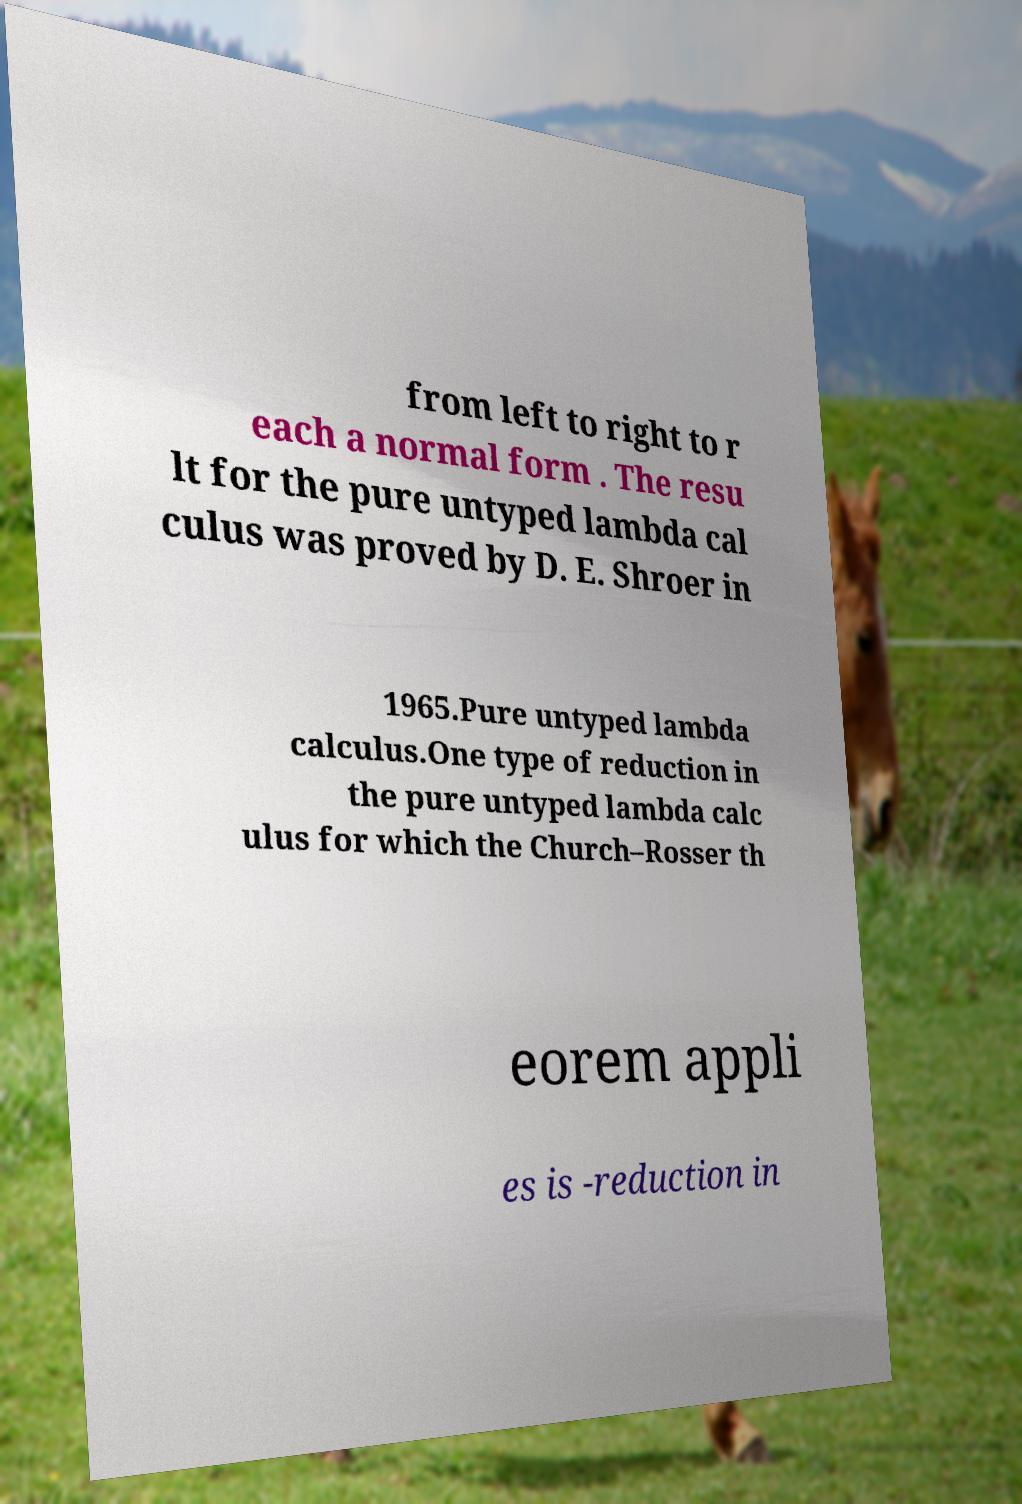Please identify and transcribe the text found in this image. from left to right to r each a normal form . The resu lt for the pure untyped lambda cal culus was proved by D. E. Shroer in 1965.Pure untyped lambda calculus.One type of reduction in the pure untyped lambda calc ulus for which the Church–Rosser th eorem appli es is -reduction in 